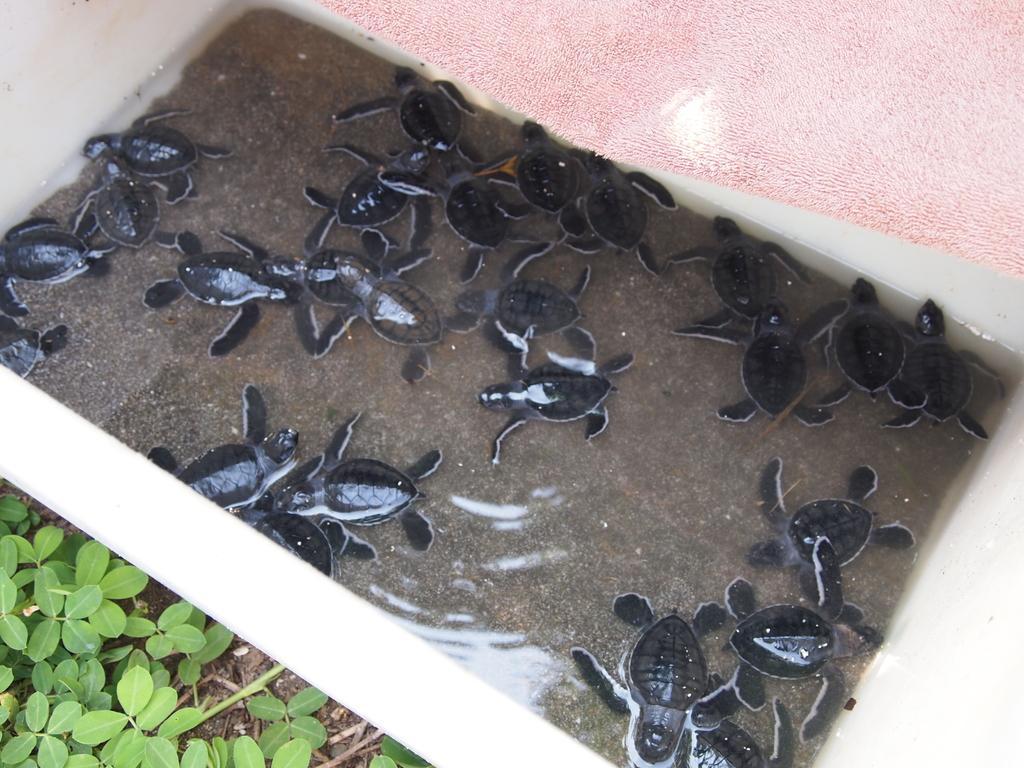How would you summarize this image in a sentence or two? In this image I can see the water, few turtles which are black in color in the water and the pink colored surface. I can see few leaves of the plant which are green in color. 